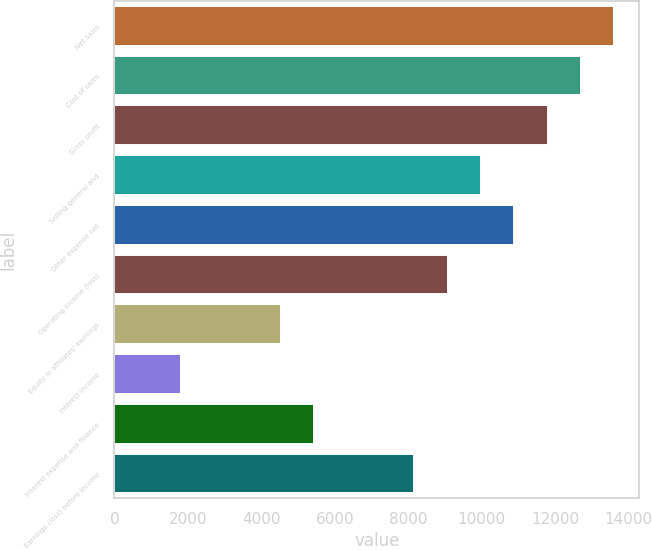Convert chart. <chart><loc_0><loc_0><loc_500><loc_500><bar_chart><fcel>Net sales<fcel>Cost of sales<fcel>Gross profit<fcel>Selling general and<fcel>Other expense net<fcel>Operating income (loss)<fcel>Equity in affiliates' earnings<fcel>Interest income<fcel>Interest expense and finance<fcel>Earnings (loss) before income<nl><fcel>13606.2<fcel>12699.2<fcel>11792.1<fcel>9978.03<fcel>10885.1<fcel>9070.99<fcel>4535.78<fcel>1814.64<fcel>5442.82<fcel>8163.94<nl></chart> 